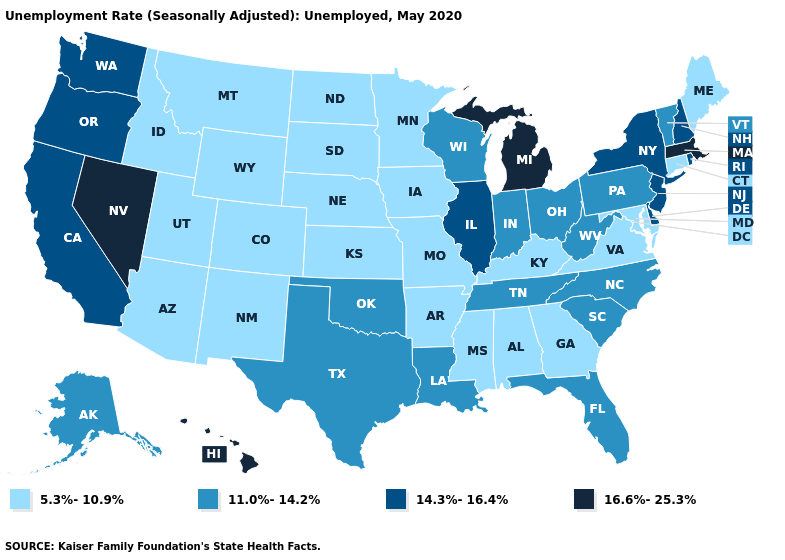Name the states that have a value in the range 14.3%-16.4%?
Answer briefly. California, Delaware, Illinois, New Hampshire, New Jersey, New York, Oregon, Rhode Island, Washington. Does Louisiana have the lowest value in the USA?
Give a very brief answer. No. What is the value of Pennsylvania?
Keep it brief. 11.0%-14.2%. Name the states that have a value in the range 16.6%-25.3%?
Write a very short answer. Hawaii, Massachusetts, Michigan, Nevada. Among the states that border Minnesota , which have the lowest value?
Answer briefly. Iowa, North Dakota, South Dakota. Name the states that have a value in the range 11.0%-14.2%?
Quick response, please. Alaska, Florida, Indiana, Louisiana, North Carolina, Ohio, Oklahoma, Pennsylvania, South Carolina, Tennessee, Texas, Vermont, West Virginia, Wisconsin. What is the value of Arizona?
Give a very brief answer. 5.3%-10.9%. Is the legend a continuous bar?
Answer briefly. No. Does Minnesota have the highest value in the USA?
Short answer required. No. Does Louisiana have the lowest value in the USA?
Keep it brief. No. What is the value of Alaska?
Quick response, please. 11.0%-14.2%. What is the value of New Mexico?
Give a very brief answer. 5.3%-10.9%. Is the legend a continuous bar?
Write a very short answer. No. Does the map have missing data?
Answer briefly. No. Does Mississippi have a lower value than Nebraska?
Quick response, please. No. 